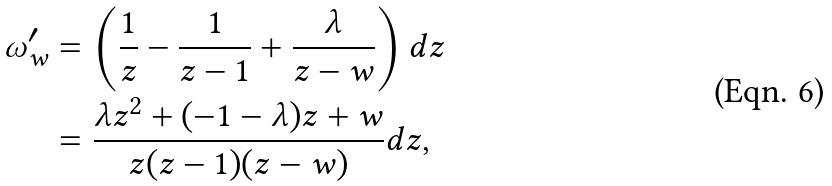<formula> <loc_0><loc_0><loc_500><loc_500>\omega _ { w } ^ { \prime } & = \left ( \frac { 1 } { z } - \frac { 1 } { z - 1 } + \frac { \lambda } { z - w } \right ) d z \\ & = \frac { \lambda z ^ { 2 } + ( - 1 - \lambda ) z + w } { z ( z - 1 ) ( z - w ) } d z ,</formula> 